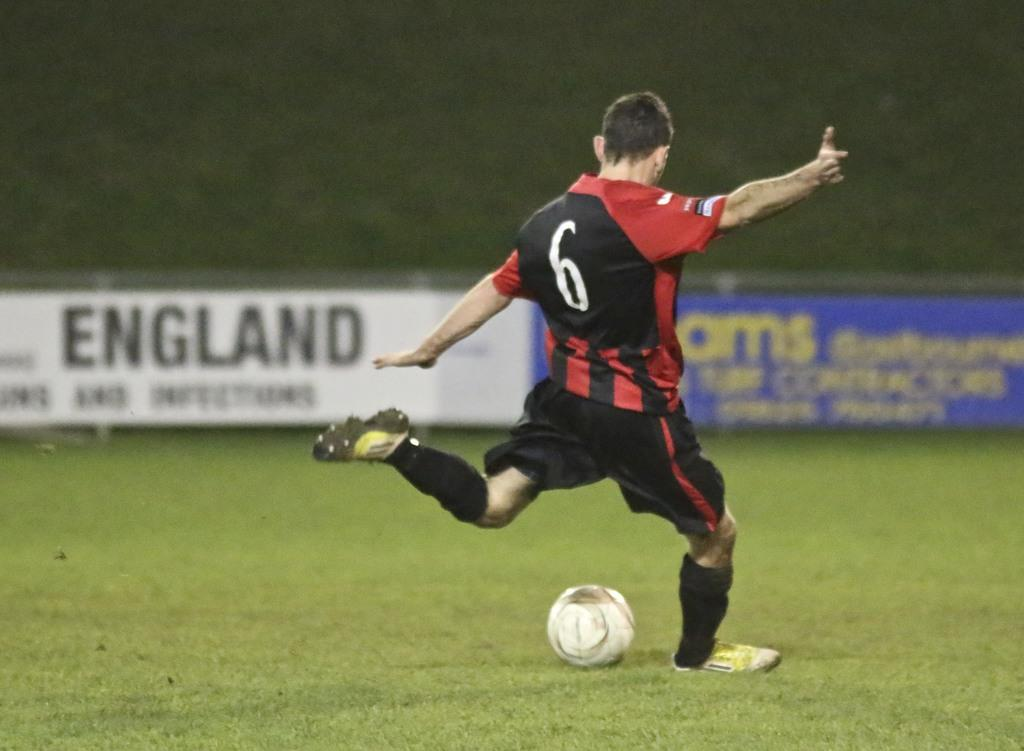<image>
Provide a brief description of the given image. Player number 6 kicks the soccer ball towards a sign that says ENGLAND 